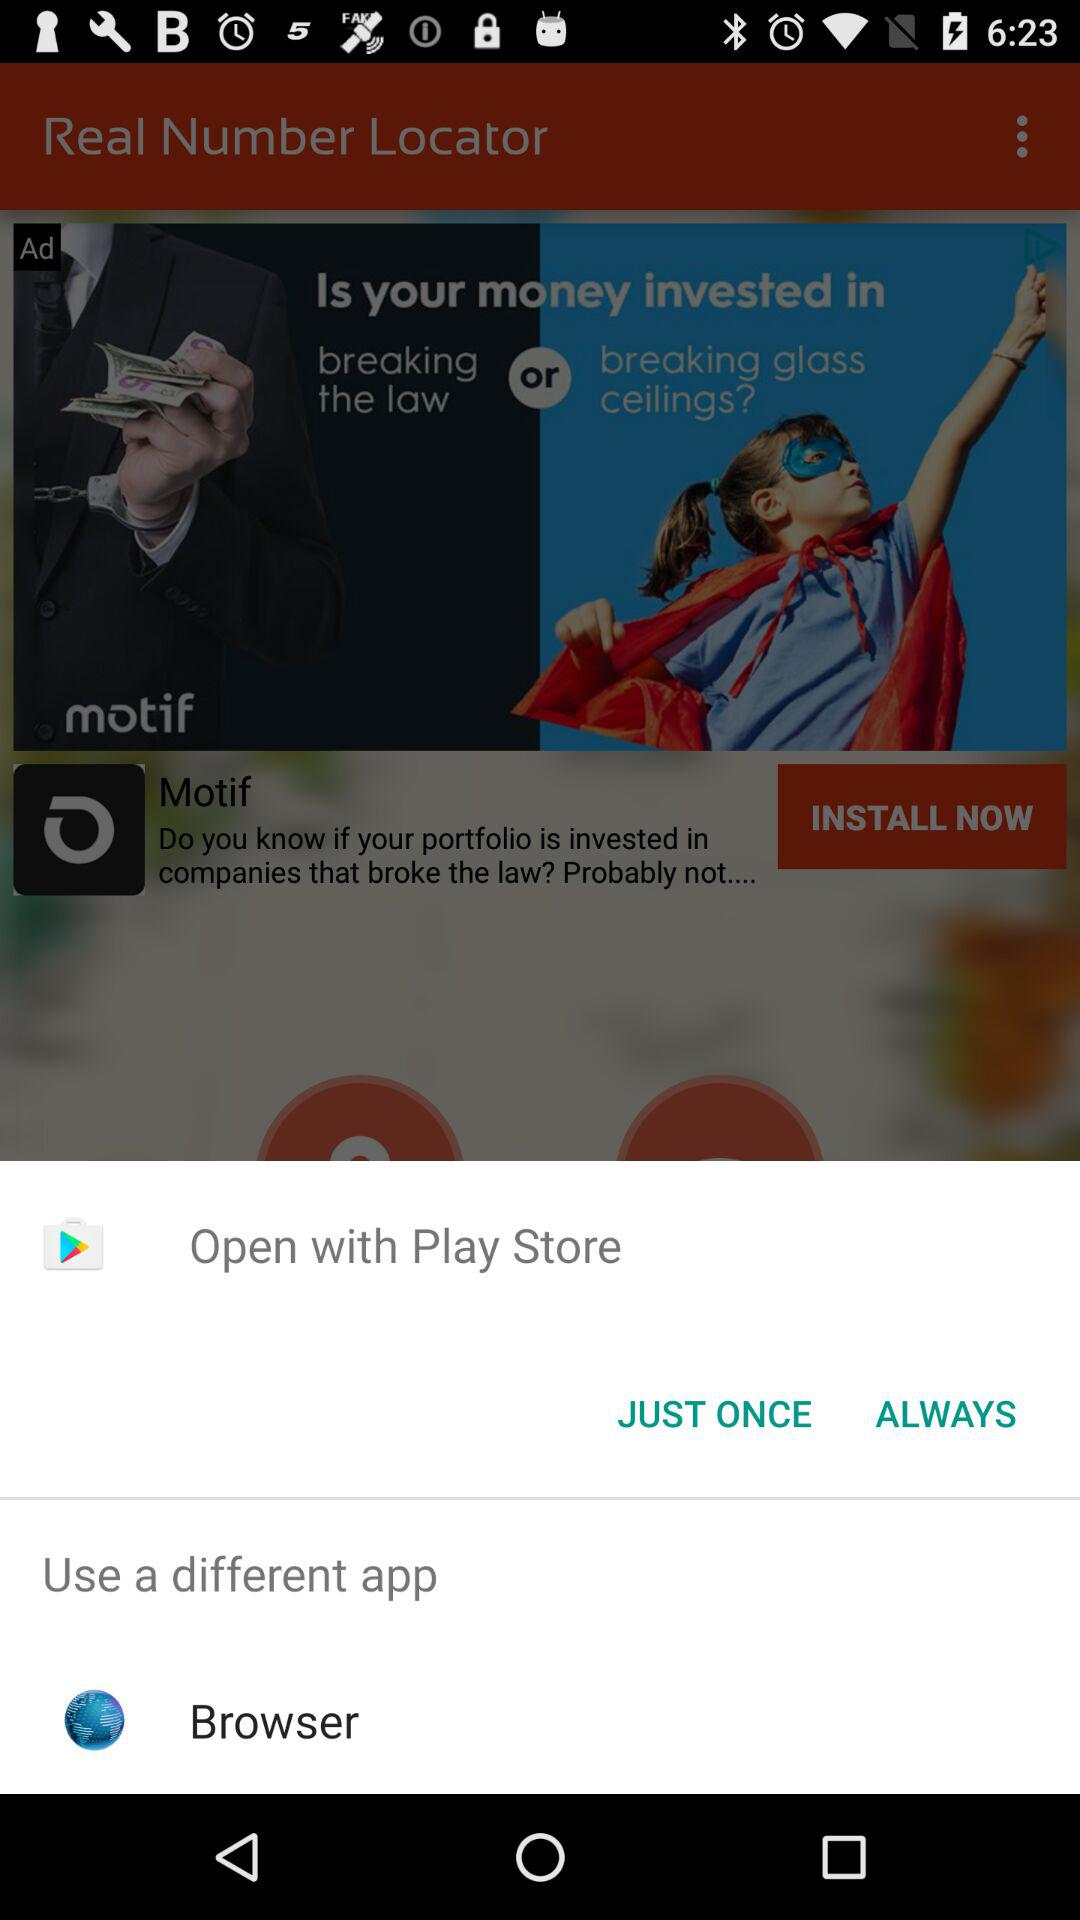What application is given for install? The given application is "Motif". 